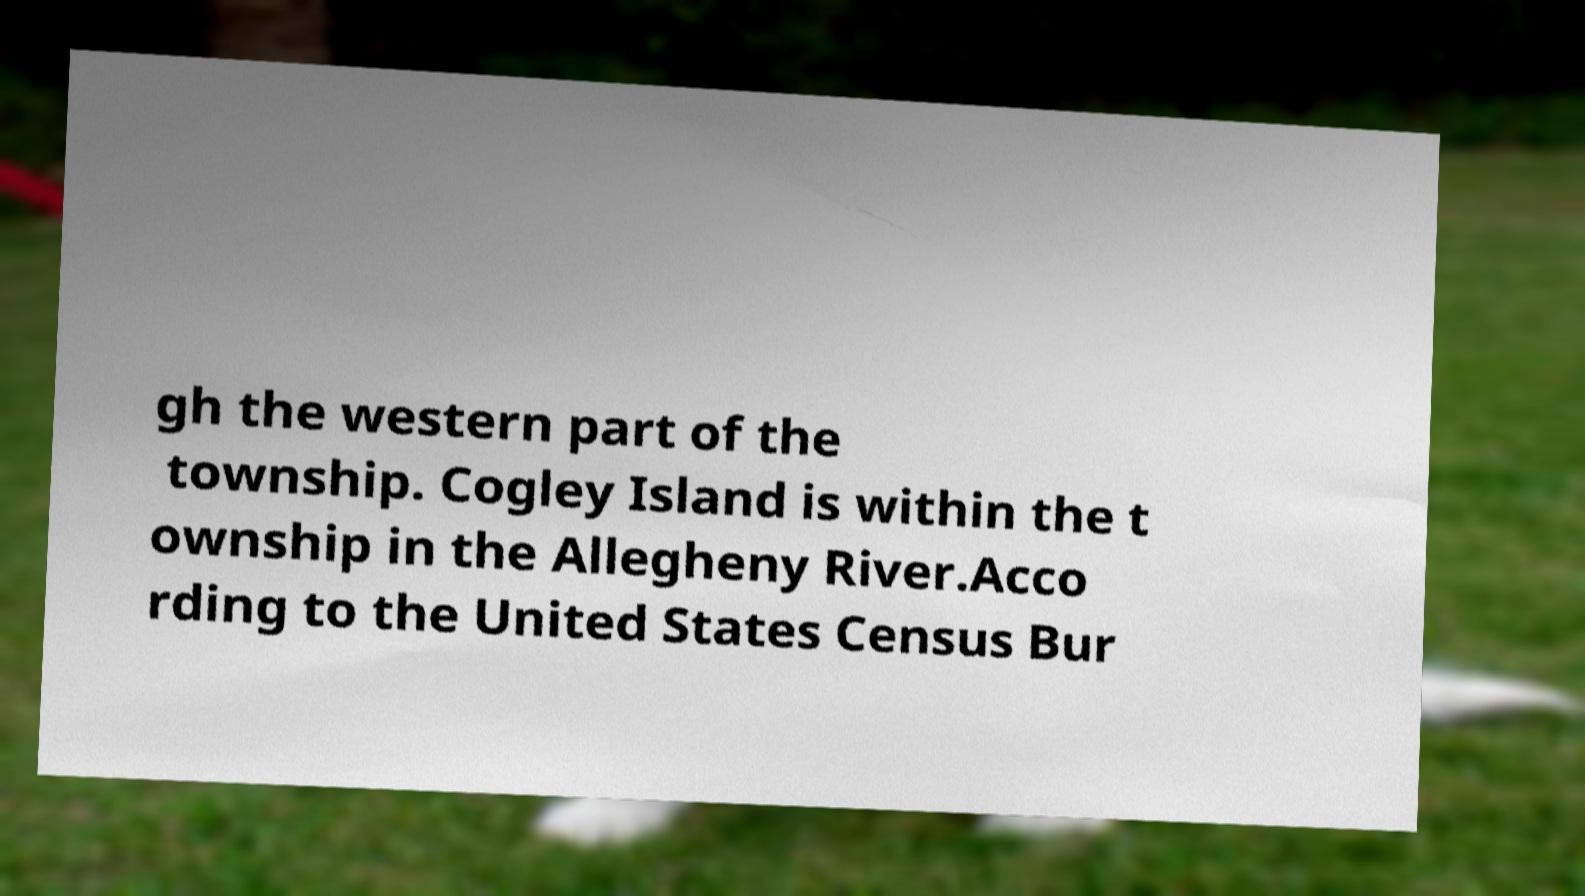Can you read and provide the text displayed in the image?This photo seems to have some interesting text. Can you extract and type it out for me? gh the western part of the township. Cogley Island is within the t ownship in the Allegheny River.Acco rding to the United States Census Bur 